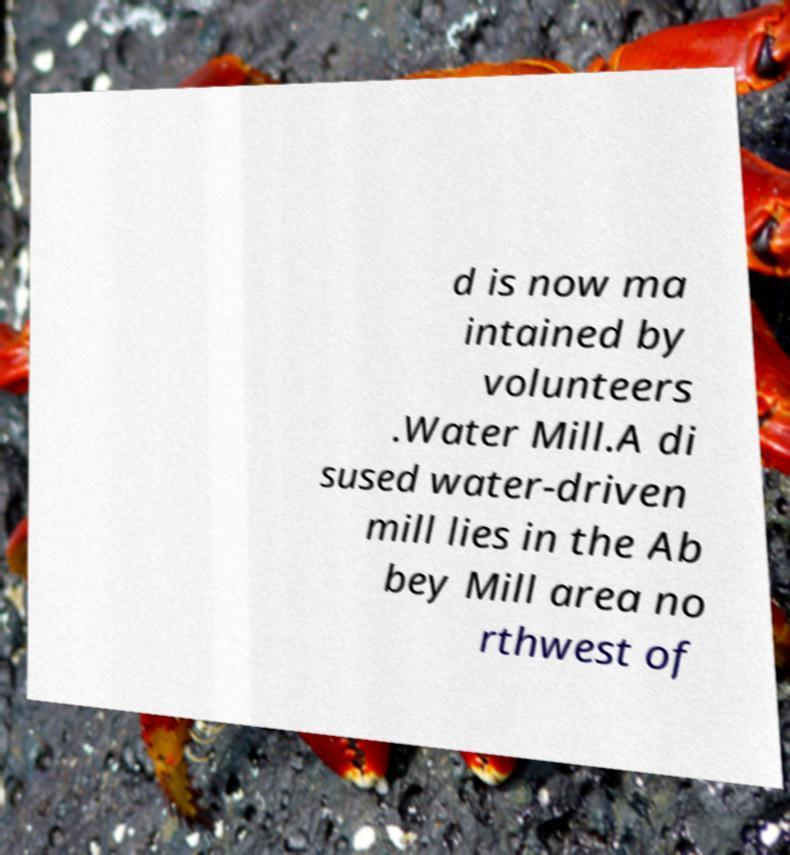Could you extract and type out the text from this image? d is now ma intained by volunteers .Water Mill.A di sused water-driven mill lies in the Ab bey Mill area no rthwest of 